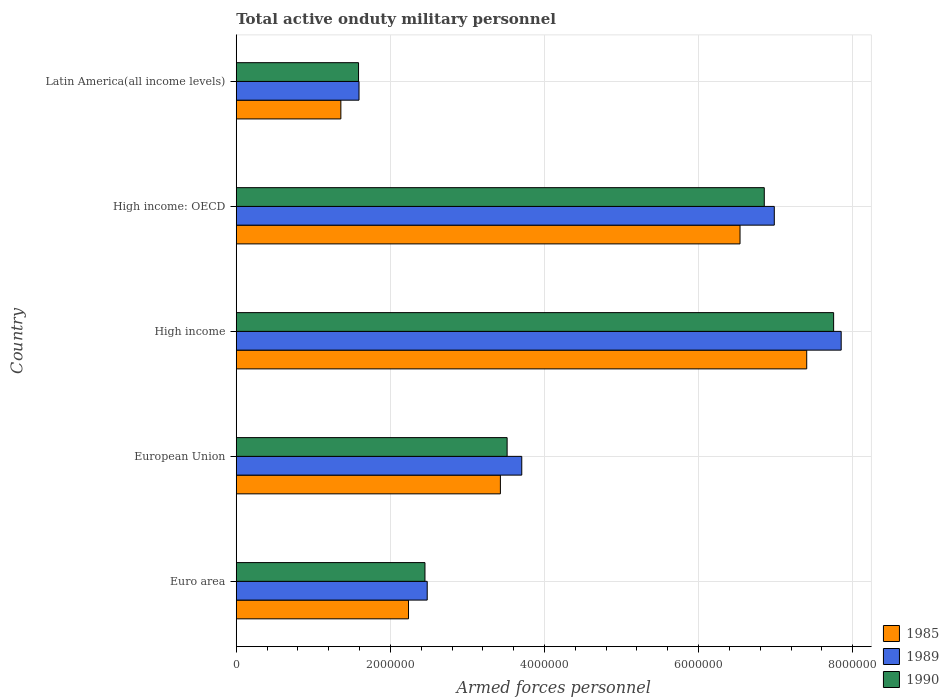How many groups of bars are there?
Offer a very short reply. 5. Are the number of bars on each tick of the Y-axis equal?
Your response must be concise. Yes. How many bars are there on the 3rd tick from the bottom?
Ensure brevity in your answer.  3. What is the number of armed forces personnel in 1985 in Euro area?
Your response must be concise. 2.24e+06. Across all countries, what is the maximum number of armed forces personnel in 1985?
Give a very brief answer. 7.40e+06. Across all countries, what is the minimum number of armed forces personnel in 1985?
Make the answer very short. 1.36e+06. In which country was the number of armed forces personnel in 1989 maximum?
Ensure brevity in your answer.  High income. In which country was the number of armed forces personnel in 1989 minimum?
Keep it short and to the point. Latin America(all income levels). What is the total number of armed forces personnel in 1985 in the graph?
Provide a short and direct response. 2.10e+07. What is the difference between the number of armed forces personnel in 1990 in Euro area and that in High income?
Make the answer very short. -5.30e+06. What is the difference between the number of armed forces personnel in 1989 in High income and the number of armed forces personnel in 1990 in European Union?
Offer a very short reply. 4.34e+06. What is the average number of armed forces personnel in 1990 per country?
Keep it short and to the point. 4.43e+06. What is the difference between the number of armed forces personnel in 1990 and number of armed forces personnel in 1985 in High income?
Make the answer very short. 3.49e+05. What is the ratio of the number of armed forces personnel in 1990 in Euro area to that in High income: OECD?
Your answer should be compact. 0.36. Is the difference between the number of armed forces personnel in 1990 in Euro area and High income greater than the difference between the number of armed forces personnel in 1985 in Euro area and High income?
Your response must be concise. No. What is the difference between the highest and the second highest number of armed forces personnel in 1985?
Offer a terse response. 8.65e+05. What is the difference between the highest and the lowest number of armed forces personnel in 1985?
Provide a succinct answer. 6.05e+06. In how many countries, is the number of armed forces personnel in 1985 greater than the average number of armed forces personnel in 1985 taken over all countries?
Give a very brief answer. 2. Is the sum of the number of armed forces personnel in 1989 in High income and High income: OECD greater than the maximum number of armed forces personnel in 1990 across all countries?
Your answer should be very brief. Yes. What does the 2nd bar from the top in Euro area represents?
Make the answer very short. 1989. Is it the case that in every country, the sum of the number of armed forces personnel in 1985 and number of armed forces personnel in 1990 is greater than the number of armed forces personnel in 1989?
Provide a short and direct response. Yes. Are all the bars in the graph horizontal?
Provide a short and direct response. Yes. What is the difference between two consecutive major ticks on the X-axis?
Offer a very short reply. 2.00e+06. Does the graph contain grids?
Provide a succinct answer. Yes. Where does the legend appear in the graph?
Your response must be concise. Bottom right. How many legend labels are there?
Keep it short and to the point. 3. What is the title of the graph?
Your answer should be very brief. Total active onduty military personnel. What is the label or title of the X-axis?
Ensure brevity in your answer.  Armed forces personnel. What is the Armed forces personnel in 1985 in Euro area?
Give a very brief answer. 2.24e+06. What is the Armed forces personnel in 1989 in Euro area?
Your response must be concise. 2.48e+06. What is the Armed forces personnel of 1990 in Euro area?
Offer a terse response. 2.45e+06. What is the Armed forces personnel in 1985 in European Union?
Offer a terse response. 3.43e+06. What is the Armed forces personnel of 1989 in European Union?
Your response must be concise. 3.70e+06. What is the Armed forces personnel in 1990 in European Union?
Provide a short and direct response. 3.52e+06. What is the Armed forces personnel in 1985 in High income?
Provide a succinct answer. 7.40e+06. What is the Armed forces personnel of 1989 in High income?
Your answer should be very brief. 7.85e+06. What is the Armed forces personnel in 1990 in High income?
Provide a succinct answer. 7.75e+06. What is the Armed forces personnel of 1985 in High income: OECD?
Ensure brevity in your answer.  6.54e+06. What is the Armed forces personnel in 1989 in High income: OECD?
Your answer should be compact. 6.98e+06. What is the Armed forces personnel in 1990 in High income: OECD?
Ensure brevity in your answer.  6.85e+06. What is the Armed forces personnel of 1985 in Latin America(all income levels)?
Your response must be concise. 1.36e+06. What is the Armed forces personnel of 1989 in Latin America(all income levels)?
Offer a terse response. 1.59e+06. What is the Armed forces personnel in 1990 in Latin America(all income levels)?
Offer a very short reply. 1.59e+06. Across all countries, what is the maximum Armed forces personnel of 1985?
Keep it short and to the point. 7.40e+06. Across all countries, what is the maximum Armed forces personnel in 1989?
Offer a terse response. 7.85e+06. Across all countries, what is the maximum Armed forces personnel of 1990?
Give a very brief answer. 7.75e+06. Across all countries, what is the minimum Armed forces personnel of 1985?
Offer a very short reply. 1.36e+06. Across all countries, what is the minimum Armed forces personnel in 1989?
Keep it short and to the point. 1.59e+06. Across all countries, what is the minimum Armed forces personnel in 1990?
Your response must be concise. 1.59e+06. What is the total Armed forces personnel in 1985 in the graph?
Provide a succinct answer. 2.10e+07. What is the total Armed forces personnel of 1989 in the graph?
Your answer should be very brief. 2.26e+07. What is the total Armed forces personnel of 1990 in the graph?
Provide a succinct answer. 2.22e+07. What is the difference between the Armed forces personnel of 1985 in Euro area and that in European Union?
Offer a terse response. -1.19e+06. What is the difference between the Armed forces personnel in 1989 in Euro area and that in European Union?
Your answer should be compact. -1.23e+06. What is the difference between the Armed forces personnel of 1990 in Euro area and that in European Union?
Provide a succinct answer. -1.07e+06. What is the difference between the Armed forces personnel of 1985 in Euro area and that in High income?
Ensure brevity in your answer.  -5.17e+06. What is the difference between the Armed forces personnel of 1989 in Euro area and that in High income?
Keep it short and to the point. -5.37e+06. What is the difference between the Armed forces personnel in 1990 in Euro area and that in High income?
Make the answer very short. -5.30e+06. What is the difference between the Armed forces personnel of 1985 in Euro area and that in High income: OECD?
Keep it short and to the point. -4.30e+06. What is the difference between the Armed forces personnel of 1989 in Euro area and that in High income: OECD?
Your response must be concise. -4.50e+06. What is the difference between the Armed forces personnel of 1990 in Euro area and that in High income: OECD?
Keep it short and to the point. -4.40e+06. What is the difference between the Armed forces personnel in 1985 in Euro area and that in Latin America(all income levels)?
Provide a short and direct response. 8.78e+05. What is the difference between the Armed forces personnel in 1989 in Euro area and that in Latin America(all income levels)?
Give a very brief answer. 8.85e+05. What is the difference between the Armed forces personnel of 1990 in Euro area and that in Latin America(all income levels)?
Your answer should be very brief. 8.62e+05. What is the difference between the Armed forces personnel of 1985 in European Union and that in High income?
Offer a very short reply. -3.98e+06. What is the difference between the Armed forces personnel of 1989 in European Union and that in High income?
Provide a succinct answer. -4.14e+06. What is the difference between the Armed forces personnel of 1990 in European Union and that in High income?
Give a very brief answer. -4.24e+06. What is the difference between the Armed forces personnel in 1985 in European Union and that in High income: OECD?
Give a very brief answer. -3.11e+06. What is the difference between the Armed forces personnel in 1989 in European Union and that in High income: OECD?
Your response must be concise. -3.28e+06. What is the difference between the Armed forces personnel of 1990 in European Union and that in High income: OECD?
Your answer should be compact. -3.34e+06. What is the difference between the Armed forces personnel of 1985 in European Union and that in Latin America(all income levels)?
Keep it short and to the point. 2.07e+06. What is the difference between the Armed forces personnel of 1989 in European Union and that in Latin America(all income levels)?
Ensure brevity in your answer.  2.11e+06. What is the difference between the Armed forces personnel of 1990 in European Union and that in Latin America(all income levels)?
Ensure brevity in your answer.  1.93e+06. What is the difference between the Armed forces personnel in 1985 in High income and that in High income: OECD?
Provide a succinct answer. 8.65e+05. What is the difference between the Armed forces personnel of 1989 in High income and that in High income: OECD?
Your answer should be compact. 8.68e+05. What is the difference between the Armed forces personnel in 1990 in High income and that in High income: OECD?
Your answer should be very brief. 9.00e+05. What is the difference between the Armed forces personnel of 1985 in High income and that in Latin America(all income levels)?
Your answer should be compact. 6.05e+06. What is the difference between the Armed forces personnel of 1989 in High income and that in Latin America(all income levels)?
Provide a succinct answer. 6.26e+06. What is the difference between the Armed forces personnel of 1990 in High income and that in Latin America(all income levels)?
Your answer should be compact. 6.16e+06. What is the difference between the Armed forces personnel in 1985 in High income: OECD and that in Latin America(all income levels)?
Provide a short and direct response. 5.18e+06. What is the difference between the Armed forces personnel of 1989 in High income: OECD and that in Latin America(all income levels)?
Give a very brief answer. 5.39e+06. What is the difference between the Armed forces personnel in 1990 in High income: OECD and that in Latin America(all income levels)?
Provide a succinct answer. 5.26e+06. What is the difference between the Armed forces personnel of 1985 in Euro area and the Armed forces personnel of 1989 in European Union?
Make the answer very short. -1.47e+06. What is the difference between the Armed forces personnel in 1985 in Euro area and the Armed forces personnel in 1990 in European Union?
Your answer should be very brief. -1.28e+06. What is the difference between the Armed forces personnel of 1989 in Euro area and the Armed forces personnel of 1990 in European Union?
Your answer should be compact. -1.04e+06. What is the difference between the Armed forces personnel in 1985 in Euro area and the Armed forces personnel in 1989 in High income?
Provide a short and direct response. -5.61e+06. What is the difference between the Armed forces personnel in 1985 in Euro area and the Armed forces personnel in 1990 in High income?
Give a very brief answer. -5.52e+06. What is the difference between the Armed forces personnel in 1989 in Euro area and the Armed forces personnel in 1990 in High income?
Offer a very short reply. -5.27e+06. What is the difference between the Armed forces personnel in 1985 in Euro area and the Armed forces personnel in 1989 in High income: OECD?
Your response must be concise. -4.75e+06. What is the difference between the Armed forces personnel of 1985 in Euro area and the Armed forces personnel of 1990 in High income: OECD?
Keep it short and to the point. -4.62e+06. What is the difference between the Armed forces personnel of 1989 in Euro area and the Armed forces personnel of 1990 in High income: OECD?
Ensure brevity in your answer.  -4.37e+06. What is the difference between the Armed forces personnel in 1985 in Euro area and the Armed forces personnel in 1989 in Latin America(all income levels)?
Provide a succinct answer. 6.42e+05. What is the difference between the Armed forces personnel in 1985 in Euro area and the Armed forces personnel in 1990 in Latin America(all income levels)?
Make the answer very short. 6.48e+05. What is the difference between the Armed forces personnel of 1989 in Euro area and the Armed forces personnel of 1990 in Latin America(all income levels)?
Keep it short and to the point. 8.91e+05. What is the difference between the Armed forces personnel of 1985 in European Union and the Armed forces personnel of 1989 in High income?
Your answer should be compact. -4.42e+06. What is the difference between the Armed forces personnel of 1985 in European Union and the Armed forces personnel of 1990 in High income?
Offer a terse response. -4.32e+06. What is the difference between the Armed forces personnel in 1989 in European Union and the Armed forces personnel in 1990 in High income?
Your response must be concise. -4.05e+06. What is the difference between the Armed forces personnel of 1985 in European Union and the Armed forces personnel of 1989 in High income: OECD?
Provide a short and direct response. -3.55e+06. What is the difference between the Armed forces personnel in 1985 in European Union and the Armed forces personnel in 1990 in High income: OECD?
Provide a succinct answer. -3.42e+06. What is the difference between the Armed forces personnel in 1989 in European Union and the Armed forces personnel in 1990 in High income: OECD?
Offer a very short reply. -3.15e+06. What is the difference between the Armed forces personnel in 1985 in European Union and the Armed forces personnel in 1989 in Latin America(all income levels)?
Your response must be concise. 1.83e+06. What is the difference between the Armed forces personnel of 1985 in European Union and the Armed forces personnel of 1990 in Latin America(all income levels)?
Keep it short and to the point. 1.84e+06. What is the difference between the Armed forces personnel in 1989 in European Union and the Armed forces personnel in 1990 in Latin America(all income levels)?
Keep it short and to the point. 2.12e+06. What is the difference between the Armed forces personnel of 1985 in High income and the Armed forces personnel of 1989 in High income: OECD?
Provide a succinct answer. 4.21e+05. What is the difference between the Armed forces personnel of 1985 in High income and the Armed forces personnel of 1990 in High income: OECD?
Make the answer very short. 5.51e+05. What is the difference between the Armed forces personnel in 1989 in High income and the Armed forces personnel in 1990 in High income: OECD?
Provide a succinct answer. 9.98e+05. What is the difference between the Armed forces personnel of 1985 in High income and the Armed forces personnel of 1989 in Latin America(all income levels)?
Give a very brief answer. 5.81e+06. What is the difference between the Armed forces personnel of 1985 in High income and the Armed forces personnel of 1990 in Latin America(all income levels)?
Ensure brevity in your answer.  5.82e+06. What is the difference between the Armed forces personnel of 1989 in High income and the Armed forces personnel of 1990 in Latin America(all income levels)?
Ensure brevity in your answer.  6.26e+06. What is the difference between the Armed forces personnel in 1985 in High income: OECD and the Armed forces personnel in 1989 in Latin America(all income levels)?
Give a very brief answer. 4.94e+06. What is the difference between the Armed forces personnel in 1985 in High income: OECD and the Armed forces personnel in 1990 in Latin America(all income levels)?
Ensure brevity in your answer.  4.95e+06. What is the difference between the Armed forces personnel in 1989 in High income: OECD and the Armed forces personnel in 1990 in Latin America(all income levels)?
Your answer should be very brief. 5.40e+06. What is the average Armed forces personnel of 1985 per country?
Your answer should be very brief. 4.19e+06. What is the average Armed forces personnel in 1989 per country?
Keep it short and to the point. 4.52e+06. What is the average Armed forces personnel of 1990 per country?
Your answer should be very brief. 4.43e+06. What is the difference between the Armed forces personnel of 1985 and Armed forces personnel of 1989 in Euro area?
Your response must be concise. -2.43e+05. What is the difference between the Armed forces personnel of 1985 and Armed forces personnel of 1990 in Euro area?
Keep it short and to the point. -2.14e+05. What is the difference between the Armed forces personnel in 1989 and Armed forces personnel in 1990 in Euro area?
Keep it short and to the point. 2.90e+04. What is the difference between the Armed forces personnel of 1985 and Armed forces personnel of 1989 in European Union?
Your answer should be very brief. -2.77e+05. What is the difference between the Armed forces personnel of 1985 and Armed forces personnel of 1990 in European Union?
Provide a succinct answer. -8.73e+04. What is the difference between the Armed forces personnel of 1989 and Armed forces personnel of 1990 in European Union?
Your answer should be compact. 1.90e+05. What is the difference between the Armed forces personnel of 1985 and Armed forces personnel of 1989 in High income?
Your answer should be compact. -4.47e+05. What is the difference between the Armed forces personnel of 1985 and Armed forces personnel of 1990 in High income?
Offer a terse response. -3.49e+05. What is the difference between the Armed forces personnel in 1989 and Armed forces personnel in 1990 in High income?
Offer a terse response. 9.80e+04. What is the difference between the Armed forces personnel of 1985 and Armed forces personnel of 1989 in High income: OECD?
Give a very brief answer. -4.45e+05. What is the difference between the Armed forces personnel of 1985 and Armed forces personnel of 1990 in High income: OECD?
Offer a terse response. -3.15e+05. What is the difference between the Armed forces personnel in 1989 and Armed forces personnel in 1990 in High income: OECD?
Keep it short and to the point. 1.30e+05. What is the difference between the Armed forces personnel of 1985 and Armed forces personnel of 1989 in Latin America(all income levels)?
Offer a very short reply. -2.36e+05. What is the difference between the Armed forces personnel of 1985 and Armed forces personnel of 1990 in Latin America(all income levels)?
Make the answer very short. -2.30e+05. What is the difference between the Armed forces personnel of 1989 and Armed forces personnel of 1990 in Latin America(all income levels)?
Give a very brief answer. 6000. What is the ratio of the Armed forces personnel in 1985 in Euro area to that in European Union?
Provide a succinct answer. 0.65. What is the ratio of the Armed forces personnel of 1989 in Euro area to that in European Union?
Give a very brief answer. 0.67. What is the ratio of the Armed forces personnel in 1990 in Euro area to that in European Union?
Provide a short and direct response. 0.7. What is the ratio of the Armed forces personnel in 1985 in Euro area to that in High income?
Offer a very short reply. 0.3. What is the ratio of the Armed forces personnel in 1989 in Euro area to that in High income?
Keep it short and to the point. 0.32. What is the ratio of the Armed forces personnel of 1990 in Euro area to that in High income?
Offer a terse response. 0.32. What is the ratio of the Armed forces personnel in 1985 in Euro area to that in High income: OECD?
Your response must be concise. 0.34. What is the ratio of the Armed forces personnel in 1989 in Euro area to that in High income: OECD?
Your response must be concise. 0.35. What is the ratio of the Armed forces personnel of 1990 in Euro area to that in High income: OECD?
Make the answer very short. 0.36. What is the ratio of the Armed forces personnel in 1985 in Euro area to that in Latin America(all income levels)?
Your answer should be compact. 1.65. What is the ratio of the Armed forces personnel of 1989 in Euro area to that in Latin America(all income levels)?
Your answer should be compact. 1.56. What is the ratio of the Armed forces personnel of 1990 in Euro area to that in Latin America(all income levels)?
Provide a succinct answer. 1.54. What is the ratio of the Armed forces personnel in 1985 in European Union to that in High income?
Make the answer very short. 0.46. What is the ratio of the Armed forces personnel of 1989 in European Union to that in High income?
Your answer should be compact. 0.47. What is the ratio of the Armed forces personnel of 1990 in European Union to that in High income?
Your response must be concise. 0.45. What is the ratio of the Armed forces personnel of 1985 in European Union to that in High income: OECD?
Your answer should be very brief. 0.52. What is the ratio of the Armed forces personnel in 1989 in European Union to that in High income: OECD?
Provide a succinct answer. 0.53. What is the ratio of the Armed forces personnel in 1990 in European Union to that in High income: OECD?
Offer a very short reply. 0.51. What is the ratio of the Armed forces personnel of 1985 in European Union to that in Latin America(all income levels)?
Offer a very short reply. 2.53. What is the ratio of the Armed forces personnel in 1989 in European Union to that in Latin America(all income levels)?
Ensure brevity in your answer.  2.33. What is the ratio of the Armed forces personnel of 1990 in European Union to that in Latin America(all income levels)?
Provide a succinct answer. 2.21. What is the ratio of the Armed forces personnel in 1985 in High income to that in High income: OECD?
Ensure brevity in your answer.  1.13. What is the ratio of the Armed forces personnel in 1989 in High income to that in High income: OECD?
Make the answer very short. 1.12. What is the ratio of the Armed forces personnel of 1990 in High income to that in High income: OECD?
Offer a terse response. 1.13. What is the ratio of the Armed forces personnel in 1985 in High income to that in Latin America(all income levels)?
Your answer should be compact. 5.45. What is the ratio of the Armed forces personnel of 1989 in High income to that in Latin America(all income levels)?
Make the answer very short. 4.93. What is the ratio of the Armed forces personnel of 1990 in High income to that in Latin America(all income levels)?
Provide a short and direct response. 4.88. What is the ratio of the Armed forces personnel of 1985 in High income: OECD to that in Latin America(all income levels)?
Keep it short and to the point. 4.82. What is the ratio of the Armed forces personnel of 1989 in High income: OECD to that in Latin America(all income levels)?
Provide a succinct answer. 4.38. What is the ratio of the Armed forces personnel of 1990 in High income: OECD to that in Latin America(all income levels)?
Your answer should be compact. 4.32. What is the difference between the highest and the second highest Armed forces personnel in 1985?
Your answer should be compact. 8.65e+05. What is the difference between the highest and the second highest Armed forces personnel of 1989?
Offer a very short reply. 8.68e+05. What is the difference between the highest and the lowest Armed forces personnel of 1985?
Ensure brevity in your answer.  6.05e+06. What is the difference between the highest and the lowest Armed forces personnel in 1989?
Offer a terse response. 6.26e+06. What is the difference between the highest and the lowest Armed forces personnel of 1990?
Provide a succinct answer. 6.16e+06. 